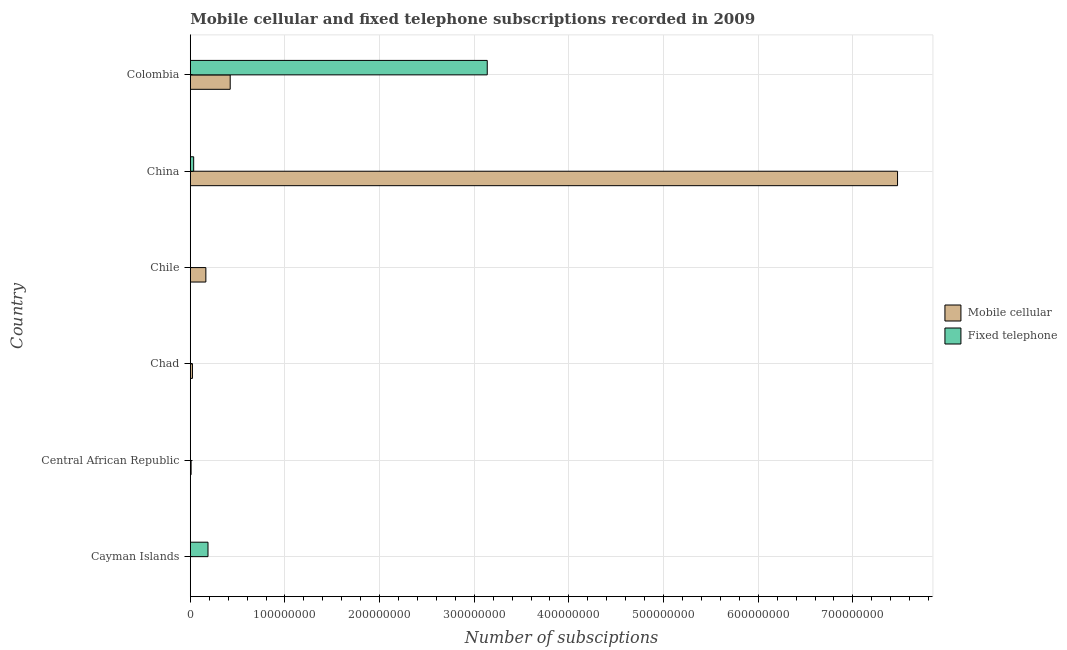How many groups of bars are there?
Your answer should be compact. 6. Are the number of bars per tick equal to the number of legend labels?
Provide a short and direct response. Yes. How many bars are there on the 6th tick from the top?
Give a very brief answer. 2. What is the label of the 5th group of bars from the top?
Keep it short and to the point. Central African Republic. What is the number of mobile cellular subscriptions in Chile?
Provide a short and direct response. 1.65e+07. Across all countries, what is the maximum number of fixed telephone subscriptions?
Provide a succinct answer. 3.14e+08. Across all countries, what is the minimum number of mobile cellular subscriptions?
Provide a succinct answer. 1.09e+05. In which country was the number of fixed telephone subscriptions maximum?
Provide a succinct answer. Colombia. In which country was the number of mobile cellular subscriptions minimum?
Your answer should be compact. Cayman Islands. What is the total number of fixed telephone subscriptions in the graph?
Provide a short and direct response. 3.36e+08. What is the difference between the number of fixed telephone subscriptions in Chad and that in Chile?
Your response must be concise. -5.47e+04. What is the difference between the number of fixed telephone subscriptions in Colombia and the number of mobile cellular subscriptions in Chile?
Keep it short and to the point. 2.97e+08. What is the average number of fixed telephone subscriptions per country?
Ensure brevity in your answer.  5.60e+07. What is the difference between the number of fixed telephone subscriptions and number of mobile cellular subscriptions in Cayman Islands?
Provide a succinct answer. 1.86e+07. In how many countries, is the number of fixed telephone subscriptions greater than 260000000 ?
Give a very brief answer. 1. What is the ratio of the number of fixed telephone subscriptions in China to that in Colombia?
Your answer should be compact. 0.01. Is the difference between the number of fixed telephone subscriptions in Cayman Islands and Chad greater than the difference between the number of mobile cellular subscriptions in Cayman Islands and Chad?
Your response must be concise. Yes. What is the difference between the highest and the second highest number of fixed telephone subscriptions?
Provide a short and direct response. 2.95e+08. What is the difference between the highest and the lowest number of mobile cellular subscriptions?
Provide a short and direct response. 7.47e+08. In how many countries, is the number of mobile cellular subscriptions greater than the average number of mobile cellular subscriptions taken over all countries?
Make the answer very short. 1. Is the sum of the number of fixed telephone subscriptions in Cayman Islands and Colombia greater than the maximum number of mobile cellular subscriptions across all countries?
Offer a very short reply. No. What does the 1st bar from the top in Central African Republic represents?
Offer a very short reply. Fixed telephone. What does the 1st bar from the bottom in Chad represents?
Your response must be concise. Mobile cellular. Are all the bars in the graph horizontal?
Your answer should be compact. Yes. How many countries are there in the graph?
Ensure brevity in your answer.  6. Are the values on the major ticks of X-axis written in scientific E-notation?
Your answer should be very brief. No. Does the graph contain any zero values?
Make the answer very short. No. Does the graph contain grids?
Make the answer very short. Yes. How many legend labels are there?
Give a very brief answer. 2. What is the title of the graph?
Ensure brevity in your answer.  Mobile cellular and fixed telephone subscriptions recorded in 2009. Does "Electricity and heat production" appear as one of the legend labels in the graph?
Offer a terse response. No. What is the label or title of the X-axis?
Provide a short and direct response. Number of subsciptions. What is the Number of subsciptions of Mobile cellular in Cayman Islands?
Ensure brevity in your answer.  1.09e+05. What is the Number of subsciptions of Fixed telephone in Cayman Islands?
Offer a terse response. 1.87e+07. What is the Number of subsciptions in Mobile cellular in Central African Republic?
Your answer should be very brief. 8.64e+05. What is the Number of subsciptions of Fixed telephone in Central African Republic?
Your answer should be compact. 3.62e+04. What is the Number of subsciptions of Mobile cellular in Chad?
Offer a terse response. 2.28e+06. What is the Number of subsciptions of Fixed telephone in Chad?
Offer a terse response. 3561. What is the Number of subsciptions of Mobile cellular in Chile?
Offer a very short reply. 1.65e+07. What is the Number of subsciptions of Fixed telephone in Chile?
Provide a short and direct response. 5.83e+04. What is the Number of subsciptions in Mobile cellular in China?
Provide a short and direct response. 7.47e+08. What is the Number of subsciptions of Fixed telephone in China?
Your answer should be compact. 3.56e+06. What is the Number of subsciptions in Mobile cellular in Colombia?
Provide a short and direct response. 4.22e+07. What is the Number of subsciptions in Fixed telephone in Colombia?
Keep it short and to the point. 3.14e+08. Across all countries, what is the maximum Number of subsciptions in Mobile cellular?
Provide a short and direct response. 7.47e+08. Across all countries, what is the maximum Number of subsciptions of Fixed telephone?
Offer a terse response. 3.14e+08. Across all countries, what is the minimum Number of subsciptions in Mobile cellular?
Provide a short and direct response. 1.09e+05. Across all countries, what is the minimum Number of subsciptions in Fixed telephone?
Offer a terse response. 3561. What is the total Number of subsciptions of Mobile cellular in the graph?
Provide a short and direct response. 8.09e+08. What is the total Number of subsciptions in Fixed telephone in the graph?
Your response must be concise. 3.36e+08. What is the difference between the Number of subsciptions in Mobile cellular in Cayman Islands and that in Central African Republic?
Ensure brevity in your answer.  -7.55e+05. What is the difference between the Number of subsciptions in Fixed telephone in Cayman Islands and that in Central African Republic?
Provide a succinct answer. 1.87e+07. What is the difference between the Number of subsciptions of Mobile cellular in Cayman Islands and that in Chad?
Offer a terse response. -2.17e+06. What is the difference between the Number of subsciptions in Fixed telephone in Cayman Islands and that in Chad?
Offer a very short reply. 1.87e+07. What is the difference between the Number of subsciptions of Mobile cellular in Cayman Islands and that in Chile?
Your answer should be compact. -1.63e+07. What is the difference between the Number of subsciptions in Fixed telephone in Cayman Islands and that in Chile?
Ensure brevity in your answer.  1.86e+07. What is the difference between the Number of subsciptions of Mobile cellular in Cayman Islands and that in China?
Provide a short and direct response. -7.47e+08. What is the difference between the Number of subsciptions of Fixed telephone in Cayman Islands and that in China?
Provide a succinct answer. 1.51e+07. What is the difference between the Number of subsciptions of Mobile cellular in Cayman Islands and that in Colombia?
Offer a very short reply. -4.21e+07. What is the difference between the Number of subsciptions of Fixed telephone in Cayman Islands and that in Colombia?
Your answer should be very brief. -2.95e+08. What is the difference between the Number of subsciptions of Mobile cellular in Central African Republic and that in Chad?
Ensure brevity in your answer.  -1.42e+06. What is the difference between the Number of subsciptions of Fixed telephone in Central African Republic and that in Chad?
Offer a terse response. 3.26e+04. What is the difference between the Number of subsciptions in Mobile cellular in Central African Republic and that in Chile?
Ensure brevity in your answer.  -1.56e+07. What is the difference between the Number of subsciptions in Fixed telephone in Central African Republic and that in Chile?
Provide a succinct answer. -2.21e+04. What is the difference between the Number of subsciptions in Mobile cellular in Central African Republic and that in China?
Give a very brief answer. -7.46e+08. What is the difference between the Number of subsciptions in Fixed telephone in Central African Republic and that in China?
Provide a succinct answer. -3.53e+06. What is the difference between the Number of subsciptions of Mobile cellular in Central African Republic and that in Colombia?
Provide a short and direct response. -4.13e+07. What is the difference between the Number of subsciptions in Fixed telephone in Central African Republic and that in Colombia?
Make the answer very short. -3.14e+08. What is the difference between the Number of subsciptions in Mobile cellular in Chad and that in Chile?
Your answer should be very brief. -1.42e+07. What is the difference between the Number of subsciptions in Fixed telephone in Chad and that in Chile?
Ensure brevity in your answer.  -5.47e+04. What is the difference between the Number of subsciptions in Mobile cellular in Chad and that in China?
Provide a short and direct response. -7.45e+08. What is the difference between the Number of subsciptions in Fixed telephone in Chad and that in China?
Offer a terse response. -3.56e+06. What is the difference between the Number of subsciptions of Mobile cellular in Chad and that in Colombia?
Provide a succinct answer. -3.99e+07. What is the difference between the Number of subsciptions of Fixed telephone in Chad and that in Colombia?
Offer a very short reply. -3.14e+08. What is the difference between the Number of subsciptions of Mobile cellular in Chile and that in China?
Make the answer very short. -7.31e+08. What is the difference between the Number of subsciptions of Fixed telephone in Chile and that in China?
Ensure brevity in your answer.  -3.51e+06. What is the difference between the Number of subsciptions in Mobile cellular in Chile and that in Colombia?
Offer a terse response. -2.57e+07. What is the difference between the Number of subsciptions of Fixed telephone in Chile and that in Colombia?
Your answer should be compact. -3.14e+08. What is the difference between the Number of subsciptions of Mobile cellular in China and that in Colombia?
Your answer should be very brief. 7.05e+08. What is the difference between the Number of subsciptions of Fixed telephone in China and that in Colombia?
Your answer should be compact. -3.10e+08. What is the difference between the Number of subsciptions in Mobile cellular in Cayman Islands and the Number of subsciptions in Fixed telephone in Central African Republic?
Offer a terse response. 7.25e+04. What is the difference between the Number of subsciptions of Mobile cellular in Cayman Islands and the Number of subsciptions of Fixed telephone in Chad?
Offer a terse response. 1.05e+05. What is the difference between the Number of subsciptions of Mobile cellular in Cayman Islands and the Number of subsciptions of Fixed telephone in Chile?
Ensure brevity in your answer.  5.04e+04. What is the difference between the Number of subsciptions in Mobile cellular in Cayman Islands and the Number of subsciptions in Fixed telephone in China?
Ensure brevity in your answer.  -3.46e+06. What is the difference between the Number of subsciptions of Mobile cellular in Cayman Islands and the Number of subsciptions of Fixed telephone in Colombia?
Give a very brief answer. -3.14e+08. What is the difference between the Number of subsciptions of Mobile cellular in Central African Republic and the Number of subsciptions of Fixed telephone in Chad?
Keep it short and to the point. 8.60e+05. What is the difference between the Number of subsciptions of Mobile cellular in Central African Republic and the Number of subsciptions of Fixed telephone in Chile?
Provide a succinct answer. 8.05e+05. What is the difference between the Number of subsciptions in Mobile cellular in Central African Republic and the Number of subsciptions in Fixed telephone in China?
Offer a very short reply. -2.70e+06. What is the difference between the Number of subsciptions of Mobile cellular in Central African Republic and the Number of subsciptions of Fixed telephone in Colombia?
Provide a short and direct response. -3.13e+08. What is the difference between the Number of subsciptions in Mobile cellular in Chad and the Number of subsciptions in Fixed telephone in Chile?
Your response must be concise. 2.22e+06. What is the difference between the Number of subsciptions of Mobile cellular in Chad and the Number of subsciptions of Fixed telephone in China?
Keep it short and to the point. -1.28e+06. What is the difference between the Number of subsciptions of Mobile cellular in Chad and the Number of subsciptions of Fixed telephone in Colombia?
Offer a terse response. -3.11e+08. What is the difference between the Number of subsciptions in Mobile cellular in Chile and the Number of subsciptions in Fixed telephone in China?
Keep it short and to the point. 1.29e+07. What is the difference between the Number of subsciptions of Mobile cellular in Chile and the Number of subsciptions of Fixed telephone in Colombia?
Your response must be concise. -2.97e+08. What is the difference between the Number of subsciptions of Mobile cellular in China and the Number of subsciptions of Fixed telephone in Colombia?
Offer a very short reply. 4.33e+08. What is the average Number of subsciptions in Mobile cellular per country?
Make the answer very short. 1.35e+08. What is the average Number of subsciptions of Fixed telephone per country?
Provide a succinct answer. 5.60e+07. What is the difference between the Number of subsciptions of Mobile cellular and Number of subsciptions of Fixed telephone in Cayman Islands?
Offer a terse response. -1.86e+07. What is the difference between the Number of subsciptions of Mobile cellular and Number of subsciptions of Fixed telephone in Central African Republic?
Offer a very short reply. 8.27e+05. What is the difference between the Number of subsciptions of Mobile cellular and Number of subsciptions of Fixed telephone in Chad?
Provide a short and direct response. 2.28e+06. What is the difference between the Number of subsciptions of Mobile cellular and Number of subsciptions of Fixed telephone in Chile?
Offer a very short reply. 1.64e+07. What is the difference between the Number of subsciptions in Mobile cellular and Number of subsciptions in Fixed telephone in China?
Give a very brief answer. 7.44e+08. What is the difference between the Number of subsciptions in Mobile cellular and Number of subsciptions in Fixed telephone in Colombia?
Your answer should be very brief. -2.72e+08. What is the ratio of the Number of subsciptions of Mobile cellular in Cayman Islands to that in Central African Republic?
Your answer should be compact. 0.13. What is the ratio of the Number of subsciptions of Fixed telephone in Cayman Islands to that in Central African Republic?
Your answer should be compact. 517.5. What is the ratio of the Number of subsciptions in Mobile cellular in Cayman Islands to that in Chad?
Make the answer very short. 0.05. What is the ratio of the Number of subsciptions in Fixed telephone in Cayman Islands to that in Chad?
Your answer should be very brief. 5253.58. What is the ratio of the Number of subsciptions in Mobile cellular in Cayman Islands to that in Chile?
Offer a terse response. 0.01. What is the ratio of the Number of subsciptions of Fixed telephone in Cayman Islands to that in Chile?
Keep it short and to the point. 321.07. What is the ratio of the Number of subsciptions of Mobile cellular in Cayman Islands to that in China?
Offer a terse response. 0. What is the ratio of the Number of subsciptions of Fixed telephone in Cayman Islands to that in China?
Ensure brevity in your answer.  5.25. What is the ratio of the Number of subsciptions of Mobile cellular in Cayman Islands to that in Colombia?
Ensure brevity in your answer.  0. What is the ratio of the Number of subsciptions in Fixed telephone in Cayman Islands to that in Colombia?
Offer a very short reply. 0.06. What is the ratio of the Number of subsciptions of Mobile cellular in Central African Republic to that in Chad?
Ensure brevity in your answer.  0.38. What is the ratio of the Number of subsciptions of Fixed telephone in Central African Republic to that in Chad?
Offer a terse response. 10.15. What is the ratio of the Number of subsciptions in Mobile cellular in Central African Republic to that in Chile?
Your response must be concise. 0.05. What is the ratio of the Number of subsciptions in Fixed telephone in Central African Republic to that in Chile?
Offer a terse response. 0.62. What is the ratio of the Number of subsciptions in Mobile cellular in Central African Republic to that in China?
Your response must be concise. 0. What is the ratio of the Number of subsciptions in Fixed telephone in Central African Republic to that in China?
Make the answer very short. 0.01. What is the ratio of the Number of subsciptions of Mobile cellular in Central African Republic to that in Colombia?
Ensure brevity in your answer.  0.02. What is the ratio of the Number of subsciptions of Fixed telephone in Central African Republic to that in Colombia?
Give a very brief answer. 0. What is the ratio of the Number of subsciptions of Mobile cellular in Chad to that in Chile?
Your response must be concise. 0.14. What is the ratio of the Number of subsciptions in Fixed telephone in Chad to that in Chile?
Provide a short and direct response. 0.06. What is the ratio of the Number of subsciptions of Mobile cellular in Chad to that in China?
Provide a succinct answer. 0. What is the ratio of the Number of subsciptions of Mobile cellular in Chad to that in Colombia?
Your answer should be compact. 0.05. What is the ratio of the Number of subsciptions of Mobile cellular in Chile to that in China?
Make the answer very short. 0.02. What is the ratio of the Number of subsciptions of Fixed telephone in Chile to that in China?
Offer a terse response. 0.02. What is the ratio of the Number of subsciptions in Mobile cellular in Chile to that in Colombia?
Offer a terse response. 0.39. What is the ratio of the Number of subsciptions of Mobile cellular in China to that in Colombia?
Your response must be concise. 17.72. What is the ratio of the Number of subsciptions in Fixed telephone in China to that in Colombia?
Make the answer very short. 0.01. What is the difference between the highest and the second highest Number of subsciptions of Mobile cellular?
Ensure brevity in your answer.  7.05e+08. What is the difference between the highest and the second highest Number of subsciptions of Fixed telephone?
Your response must be concise. 2.95e+08. What is the difference between the highest and the lowest Number of subsciptions of Mobile cellular?
Your answer should be very brief. 7.47e+08. What is the difference between the highest and the lowest Number of subsciptions of Fixed telephone?
Make the answer very short. 3.14e+08. 